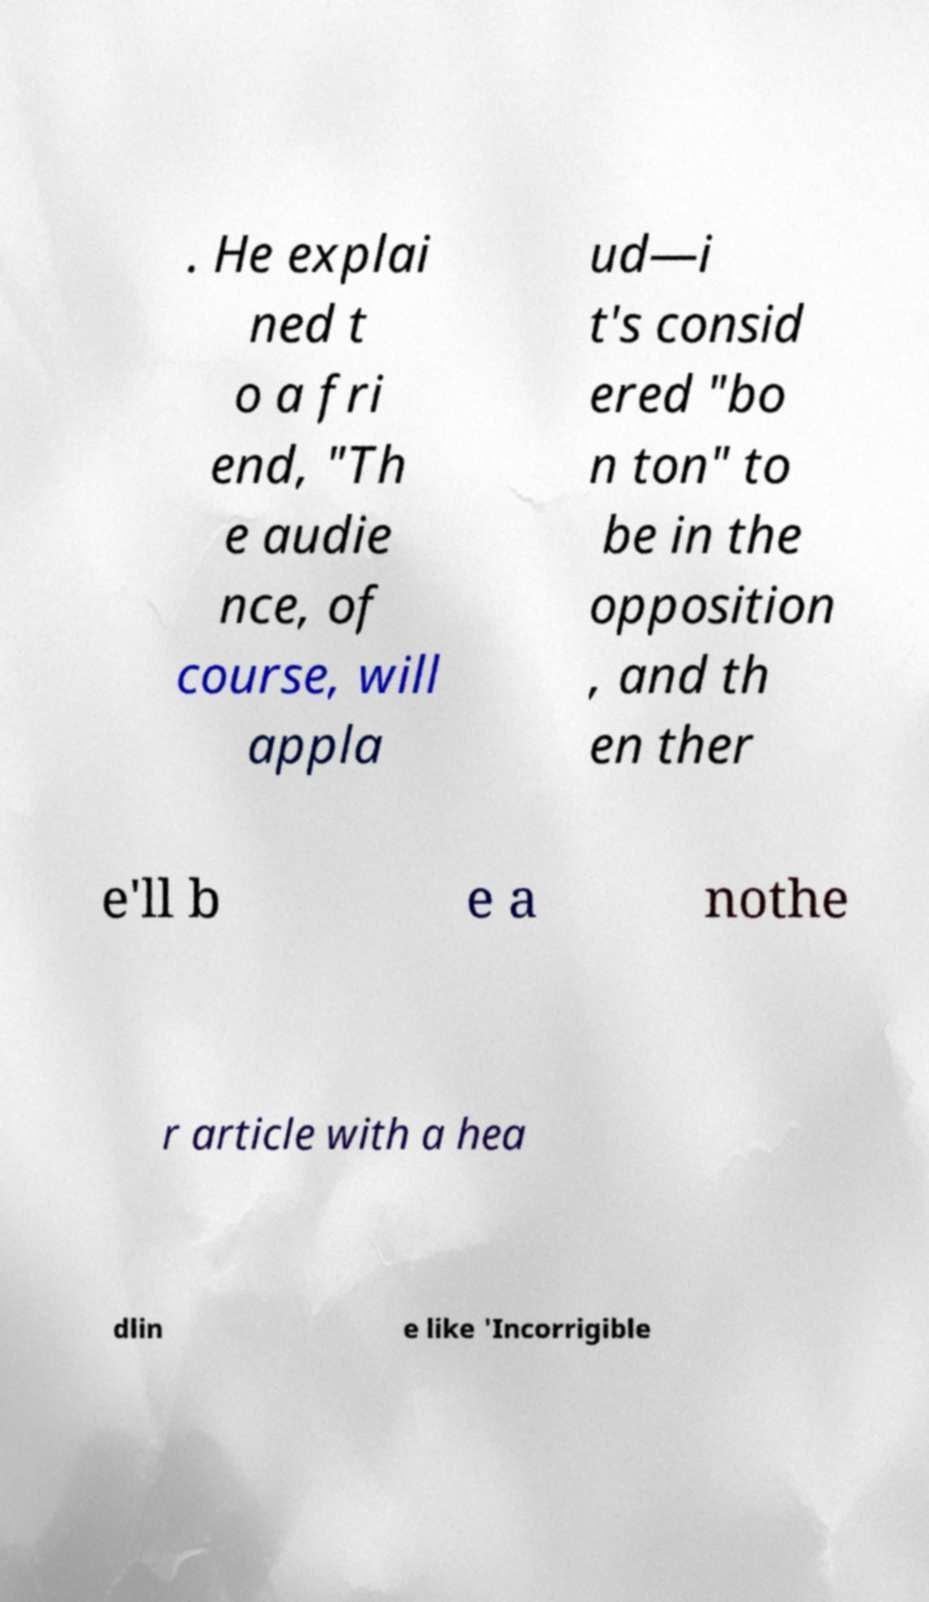What messages or text are displayed in this image? I need them in a readable, typed format. . He explai ned t o a fri end, "Th e audie nce, of course, will appla ud—i t's consid ered "bo n ton" to be in the opposition , and th en ther e'll b e a nothe r article with a hea dlin e like 'Incorrigible 